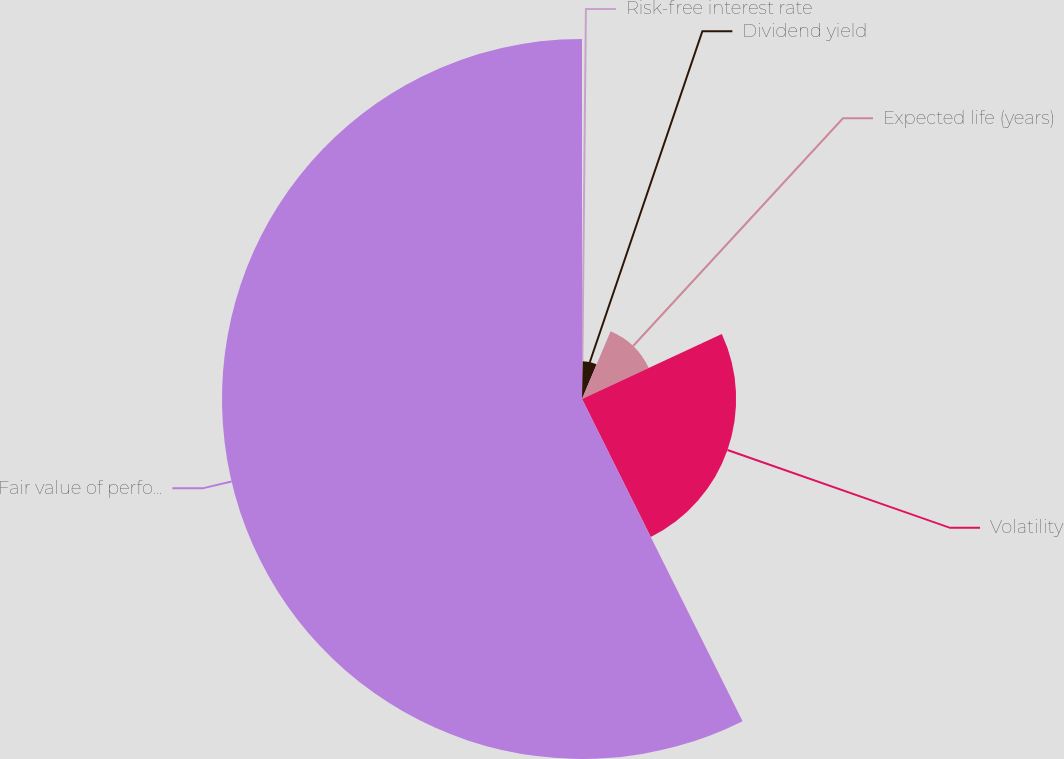Convert chart. <chart><loc_0><loc_0><loc_500><loc_500><pie_chart><fcel>Risk-free interest rate<fcel>Dividend yield<fcel>Expected life (years)<fcel>Volatility<fcel>Fair value of performance<nl><fcel>0.32%<fcel>6.03%<fcel>11.73%<fcel>24.56%<fcel>57.36%<nl></chart> 